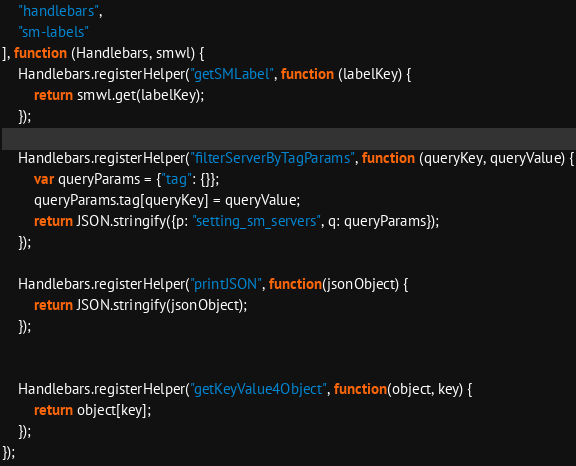<code> <loc_0><loc_0><loc_500><loc_500><_JavaScript_>    "handlebars",
    "sm-labels"
], function (Handlebars, smwl) {
    Handlebars.registerHelper("getSMLabel", function (labelKey) {
        return smwl.get(labelKey);
    });

    Handlebars.registerHelper("filterServerByTagParams", function (queryKey, queryValue) {
        var queryParams = {"tag": {}};
        queryParams.tag[queryKey] = queryValue;
        return JSON.stringify({p: "setting_sm_servers", q: queryParams});
    });

    Handlebars.registerHelper("printJSON", function(jsonObject) {
        return JSON.stringify(jsonObject);
    });


    Handlebars.registerHelper("getKeyValue4Object", function(object, key) {
        return object[key];
    });
});
</code> 